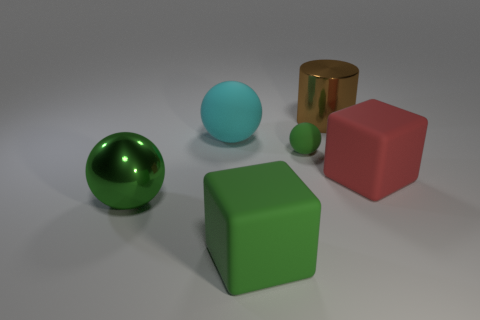Subtract all small spheres. How many spheres are left? 2 Subtract all cyan balls. How many balls are left? 2 Add 1 small blue shiny blocks. How many objects exist? 7 Subtract all cylinders. How many objects are left? 5 Subtract 1 cylinders. How many cylinders are left? 0 Subtract all purple balls. How many blue cylinders are left? 0 Subtract 1 cyan balls. How many objects are left? 5 Subtract all purple spheres. Subtract all purple blocks. How many spheres are left? 3 Subtract all red metallic spheres. Subtract all red matte blocks. How many objects are left? 5 Add 3 red matte cubes. How many red matte cubes are left? 4 